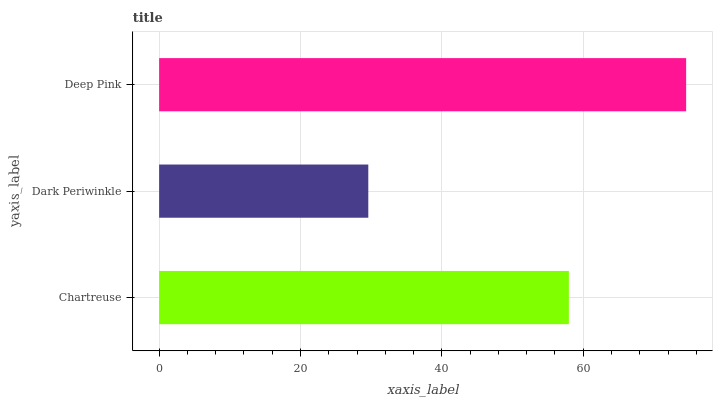Is Dark Periwinkle the minimum?
Answer yes or no. Yes. Is Deep Pink the maximum?
Answer yes or no. Yes. Is Deep Pink the minimum?
Answer yes or no. No. Is Dark Periwinkle the maximum?
Answer yes or no. No. Is Deep Pink greater than Dark Periwinkle?
Answer yes or no. Yes. Is Dark Periwinkle less than Deep Pink?
Answer yes or no. Yes. Is Dark Periwinkle greater than Deep Pink?
Answer yes or no. No. Is Deep Pink less than Dark Periwinkle?
Answer yes or no. No. Is Chartreuse the high median?
Answer yes or no. Yes. Is Chartreuse the low median?
Answer yes or no. Yes. Is Dark Periwinkle the high median?
Answer yes or no. No. Is Deep Pink the low median?
Answer yes or no. No. 